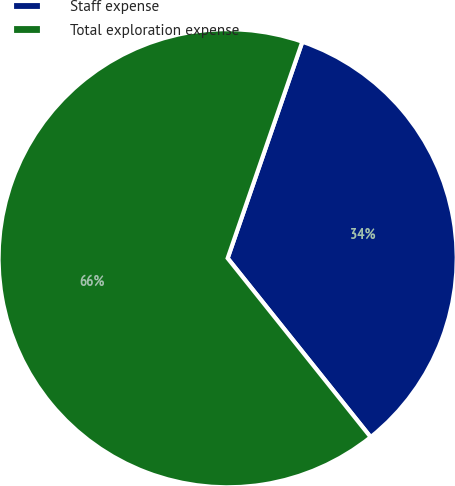<chart> <loc_0><loc_0><loc_500><loc_500><pie_chart><fcel>Staff expense<fcel>Total exploration expense<nl><fcel>33.98%<fcel>66.02%<nl></chart> 